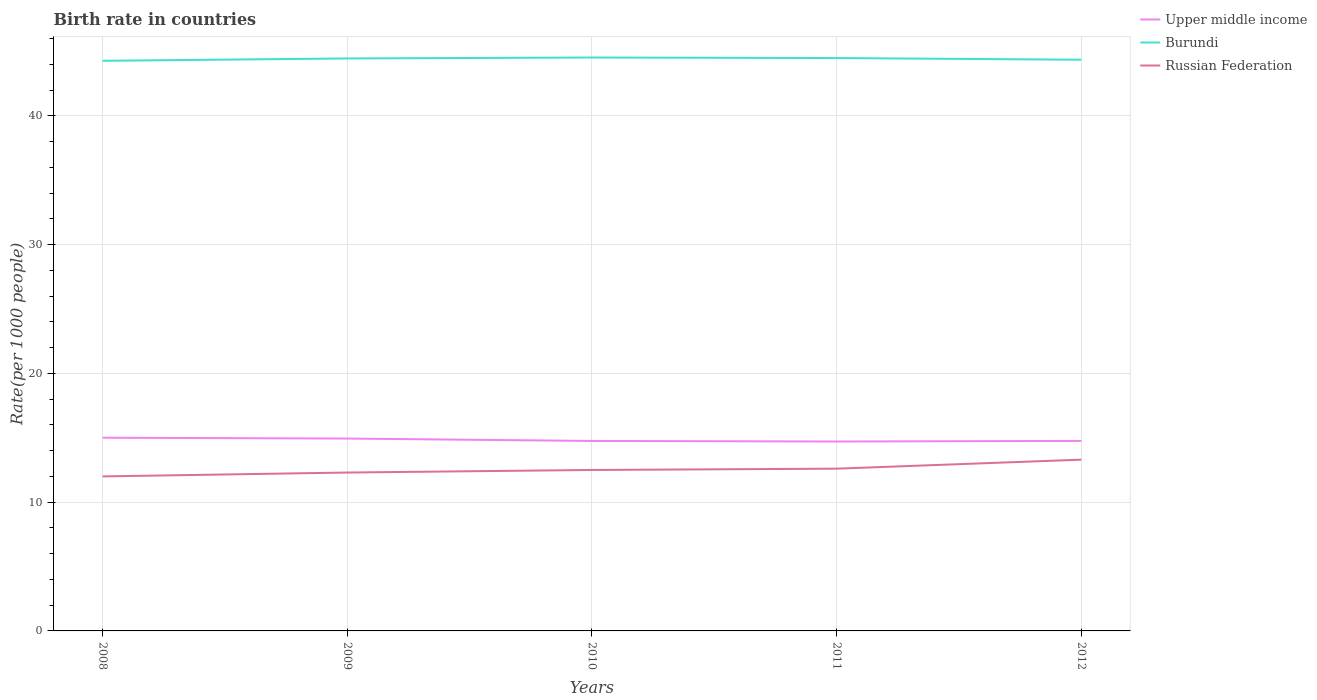Across all years, what is the maximum birth rate in Russian Federation?
Make the answer very short. 12. What is the total birth rate in Russian Federation in the graph?
Make the answer very short. -0.6. What is the difference between the highest and the second highest birth rate in Upper middle income?
Keep it short and to the point. 0.29. How many years are there in the graph?
Ensure brevity in your answer.  5. What is the title of the graph?
Give a very brief answer. Birth rate in countries. Does "Burundi" appear as one of the legend labels in the graph?
Give a very brief answer. Yes. What is the label or title of the X-axis?
Your answer should be very brief. Years. What is the label or title of the Y-axis?
Make the answer very short. Rate(per 1000 people). What is the Rate(per 1000 people) of Upper middle income in 2008?
Offer a terse response. 15.01. What is the Rate(per 1000 people) of Burundi in 2008?
Provide a short and direct response. 44.28. What is the Rate(per 1000 people) of Upper middle income in 2009?
Your answer should be compact. 14.94. What is the Rate(per 1000 people) in Burundi in 2009?
Provide a succinct answer. 44.46. What is the Rate(per 1000 people) of Upper middle income in 2010?
Give a very brief answer. 14.75. What is the Rate(per 1000 people) of Burundi in 2010?
Offer a very short reply. 44.53. What is the Rate(per 1000 people) of Upper middle income in 2011?
Ensure brevity in your answer.  14.71. What is the Rate(per 1000 people) of Burundi in 2011?
Provide a succinct answer. 44.49. What is the Rate(per 1000 people) of Russian Federation in 2011?
Offer a terse response. 12.6. What is the Rate(per 1000 people) in Upper middle income in 2012?
Your answer should be compact. 14.76. What is the Rate(per 1000 people) of Burundi in 2012?
Ensure brevity in your answer.  44.36. What is the Rate(per 1000 people) of Russian Federation in 2012?
Offer a very short reply. 13.3. Across all years, what is the maximum Rate(per 1000 people) of Upper middle income?
Provide a short and direct response. 15.01. Across all years, what is the maximum Rate(per 1000 people) of Burundi?
Make the answer very short. 44.53. Across all years, what is the maximum Rate(per 1000 people) of Russian Federation?
Provide a short and direct response. 13.3. Across all years, what is the minimum Rate(per 1000 people) in Upper middle income?
Your response must be concise. 14.71. Across all years, what is the minimum Rate(per 1000 people) in Burundi?
Make the answer very short. 44.28. What is the total Rate(per 1000 people) in Upper middle income in the graph?
Your answer should be very brief. 74.16. What is the total Rate(per 1000 people) in Burundi in the graph?
Offer a very short reply. 222.11. What is the total Rate(per 1000 people) in Russian Federation in the graph?
Provide a succinct answer. 62.7. What is the difference between the Rate(per 1000 people) in Upper middle income in 2008 and that in 2009?
Your answer should be compact. 0.07. What is the difference between the Rate(per 1000 people) in Burundi in 2008 and that in 2009?
Your answer should be very brief. -0.18. What is the difference between the Rate(per 1000 people) in Upper middle income in 2008 and that in 2010?
Provide a short and direct response. 0.25. What is the difference between the Rate(per 1000 people) in Burundi in 2008 and that in 2010?
Your answer should be compact. -0.25. What is the difference between the Rate(per 1000 people) in Russian Federation in 2008 and that in 2010?
Keep it short and to the point. -0.5. What is the difference between the Rate(per 1000 people) of Upper middle income in 2008 and that in 2011?
Make the answer very short. 0.29. What is the difference between the Rate(per 1000 people) in Burundi in 2008 and that in 2011?
Make the answer very short. -0.21. What is the difference between the Rate(per 1000 people) in Russian Federation in 2008 and that in 2011?
Your response must be concise. -0.6. What is the difference between the Rate(per 1000 people) in Upper middle income in 2008 and that in 2012?
Give a very brief answer. 0.25. What is the difference between the Rate(per 1000 people) in Burundi in 2008 and that in 2012?
Offer a terse response. -0.08. What is the difference between the Rate(per 1000 people) in Russian Federation in 2008 and that in 2012?
Ensure brevity in your answer.  -1.3. What is the difference between the Rate(per 1000 people) in Upper middle income in 2009 and that in 2010?
Make the answer very short. 0.18. What is the difference between the Rate(per 1000 people) in Burundi in 2009 and that in 2010?
Provide a short and direct response. -0.07. What is the difference between the Rate(per 1000 people) in Russian Federation in 2009 and that in 2010?
Keep it short and to the point. -0.2. What is the difference between the Rate(per 1000 people) of Upper middle income in 2009 and that in 2011?
Your response must be concise. 0.23. What is the difference between the Rate(per 1000 people) in Burundi in 2009 and that in 2011?
Give a very brief answer. -0.03. What is the difference between the Rate(per 1000 people) in Russian Federation in 2009 and that in 2011?
Ensure brevity in your answer.  -0.3. What is the difference between the Rate(per 1000 people) of Upper middle income in 2009 and that in 2012?
Ensure brevity in your answer.  0.18. What is the difference between the Rate(per 1000 people) in Burundi in 2009 and that in 2012?
Keep it short and to the point. 0.1. What is the difference between the Rate(per 1000 people) in Russian Federation in 2009 and that in 2012?
Your response must be concise. -1. What is the difference between the Rate(per 1000 people) of Upper middle income in 2010 and that in 2011?
Offer a terse response. 0.04. What is the difference between the Rate(per 1000 people) in Burundi in 2010 and that in 2011?
Your answer should be very brief. 0.04. What is the difference between the Rate(per 1000 people) in Russian Federation in 2010 and that in 2011?
Provide a succinct answer. -0.1. What is the difference between the Rate(per 1000 people) of Upper middle income in 2010 and that in 2012?
Your response must be concise. -0. What is the difference between the Rate(per 1000 people) of Burundi in 2010 and that in 2012?
Your answer should be compact. 0.17. What is the difference between the Rate(per 1000 people) in Russian Federation in 2010 and that in 2012?
Your answer should be compact. -0.8. What is the difference between the Rate(per 1000 people) in Upper middle income in 2011 and that in 2012?
Your answer should be very brief. -0.04. What is the difference between the Rate(per 1000 people) in Burundi in 2011 and that in 2012?
Provide a short and direct response. 0.13. What is the difference between the Rate(per 1000 people) in Russian Federation in 2011 and that in 2012?
Your answer should be compact. -0.7. What is the difference between the Rate(per 1000 people) of Upper middle income in 2008 and the Rate(per 1000 people) of Burundi in 2009?
Your answer should be very brief. -29.45. What is the difference between the Rate(per 1000 people) in Upper middle income in 2008 and the Rate(per 1000 people) in Russian Federation in 2009?
Provide a short and direct response. 2.71. What is the difference between the Rate(per 1000 people) of Burundi in 2008 and the Rate(per 1000 people) of Russian Federation in 2009?
Your response must be concise. 31.98. What is the difference between the Rate(per 1000 people) of Upper middle income in 2008 and the Rate(per 1000 people) of Burundi in 2010?
Keep it short and to the point. -29.52. What is the difference between the Rate(per 1000 people) in Upper middle income in 2008 and the Rate(per 1000 people) in Russian Federation in 2010?
Give a very brief answer. 2.51. What is the difference between the Rate(per 1000 people) in Burundi in 2008 and the Rate(per 1000 people) in Russian Federation in 2010?
Offer a very short reply. 31.78. What is the difference between the Rate(per 1000 people) of Upper middle income in 2008 and the Rate(per 1000 people) of Burundi in 2011?
Ensure brevity in your answer.  -29.48. What is the difference between the Rate(per 1000 people) of Upper middle income in 2008 and the Rate(per 1000 people) of Russian Federation in 2011?
Your response must be concise. 2.41. What is the difference between the Rate(per 1000 people) in Burundi in 2008 and the Rate(per 1000 people) in Russian Federation in 2011?
Make the answer very short. 31.68. What is the difference between the Rate(per 1000 people) of Upper middle income in 2008 and the Rate(per 1000 people) of Burundi in 2012?
Make the answer very short. -29.35. What is the difference between the Rate(per 1000 people) in Upper middle income in 2008 and the Rate(per 1000 people) in Russian Federation in 2012?
Offer a terse response. 1.71. What is the difference between the Rate(per 1000 people) in Burundi in 2008 and the Rate(per 1000 people) in Russian Federation in 2012?
Your answer should be very brief. 30.98. What is the difference between the Rate(per 1000 people) in Upper middle income in 2009 and the Rate(per 1000 people) in Burundi in 2010?
Offer a terse response. -29.59. What is the difference between the Rate(per 1000 people) in Upper middle income in 2009 and the Rate(per 1000 people) in Russian Federation in 2010?
Provide a succinct answer. 2.44. What is the difference between the Rate(per 1000 people) of Burundi in 2009 and the Rate(per 1000 people) of Russian Federation in 2010?
Give a very brief answer. 31.96. What is the difference between the Rate(per 1000 people) in Upper middle income in 2009 and the Rate(per 1000 people) in Burundi in 2011?
Make the answer very short. -29.55. What is the difference between the Rate(per 1000 people) in Upper middle income in 2009 and the Rate(per 1000 people) in Russian Federation in 2011?
Provide a succinct answer. 2.34. What is the difference between the Rate(per 1000 people) in Burundi in 2009 and the Rate(per 1000 people) in Russian Federation in 2011?
Provide a short and direct response. 31.86. What is the difference between the Rate(per 1000 people) in Upper middle income in 2009 and the Rate(per 1000 people) in Burundi in 2012?
Give a very brief answer. -29.42. What is the difference between the Rate(per 1000 people) in Upper middle income in 2009 and the Rate(per 1000 people) in Russian Federation in 2012?
Offer a very short reply. 1.64. What is the difference between the Rate(per 1000 people) of Burundi in 2009 and the Rate(per 1000 people) of Russian Federation in 2012?
Provide a short and direct response. 31.16. What is the difference between the Rate(per 1000 people) of Upper middle income in 2010 and the Rate(per 1000 people) of Burundi in 2011?
Ensure brevity in your answer.  -29.74. What is the difference between the Rate(per 1000 people) of Upper middle income in 2010 and the Rate(per 1000 people) of Russian Federation in 2011?
Ensure brevity in your answer.  2.15. What is the difference between the Rate(per 1000 people) of Burundi in 2010 and the Rate(per 1000 people) of Russian Federation in 2011?
Provide a succinct answer. 31.93. What is the difference between the Rate(per 1000 people) in Upper middle income in 2010 and the Rate(per 1000 people) in Burundi in 2012?
Your response must be concise. -29.6. What is the difference between the Rate(per 1000 people) of Upper middle income in 2010 and the Rate(per 1000 people) of Russian Federation in 2012?
Offer a terse response. 1.45. What is the difference between the Rate(per 1000 people) of Burundi in 2010 and the Rate(per 1000 people) of Russian Federation in 2012?
Your answer should be very brief. 31.23. What is the difference between the Rate(per 1000 people) of Upper middle income in 2011 and the Rate(per 1000 people) of Burundi in 2012?
Give a very brief answer. -29.65. What is the difference between the Rate(per 1000 people) of Upper middle income in 2011 and the Rate(per 1000 people) of Russian Federation in 2012?
Make the answer very short. 1.41. What is the difference between the Rate(per 1000 people) of Burundi in 2011 and the Rate(per 1000 people) of Russian Federation in 2012?
Provide a succinct answer. 31.19. What is the average Rate(per 1000 people) in Upper middle income per year?
Provide a succinct answer. 14.83. What is the average Rate(per 1000 people) of Burundi per year?
Provide a succinct answer. 44.42. What is the average Rate(per 1000 people) of Russian Federation per year?
Make the answer very short. 12.54. In the year 2008, what is the difference between the Rate(per 1000 people) in Upper middle income and Rate(per 1000 people) in Burundi?
Make the answer very short. -29.27. In the year 2008, what is the difference between the Rate(per 1000 people) of Upper middle income and Rate(per 1000 people) of Russian Federation?
Make the answer very short. 3.01. In the year 2008, what is the difference between the Rate(per 1000 people) in Burundi and Rate(per 1000 people) in Russian Federation?
Your response must be concise. 32.28. In the year 2009, what is the difference between the Rate(per 1000 people) of Upper middle income and Rate(per 1000 people) of Burundi?
Your answer should be very brief. -29.52. In the year 2009, what is the difference between the Rate(per 1000 people) in Upper middle income and Rate(per 1000 people) in Russian Federation?
Your response must be concise. 2.64. In the year 2009, what is the difference between the Rate(per 1000 people) in Burundi and Rate(per 1000 people) in Russian Federation?
Provide a short and direct response. 32.16. In the year 2010, what is the difference between the Rate(per 1000 people) of Upper middle income and Rate(per 1000 people) of Burundi?
Your answer should be compact. -29.78. In the year 2010, what is the difference between the Rate(per 1000 people) of Upper middle income and Rate(per 1000 people) of Russian Federation?
Offer a terse response. 2.25. In the year 2010, what is the difference between the Rate(per 1000 people) of Burundi and Rate(per 1000 people) of Russian Federation?
Your answer should be very brief. 32.03. In the year 2011, what is the difference between the Rate(per 1000 people) of Upper middle income and Rate(per 1000 people) of Burundi?
Your answer should be very brief. -29.78. In the year 2011, what is the difference between the Rate(per 1000 people) of Upper middle income and Rate(per 1000 people) of Russian Federation?
Your response must be concise. 2.11. In the year 2011, what is the difference between the Rate(per 1000 people) of Burundi and Rate(per 1000 people) of Russian Federation?
Provide a short and direct response. 31.89. In the year 2012, what is the difference between the Rate(per 1000 people) of Upper middle income and Rate(per 1000 people) of Burundi?
Your response must be concise. -29.6. In the year 2012, what is the difference between the Rate(per 1000 people) of Upper middle income and Rate(per 1000 people) of Russian Federation?
Keep it short and to the point. 1.46. In the year 2012, what is the difference between the Rate(per 1000 people) in Burundi and Rate(per 1000 people) in Russian Federation?
Your answer should be very brief. 31.06. What is the ratio of the Rate(per 1000 people) in Burundi in 2008 to that in 2009?
Offer a terse response. 1. What is the ratio of the Rate(per 1000 people) in Russian Federation in 2008 to that in 2009?
Offer a terse response. 0.98. What is the ratio of the Rate(per 1000 people) of Upper middle income in 2008 to that in 2010?
Your answer should be very brief. 1.02. What is the ratio of the Rate(per 1000 people) of Russian Federation in 2008 to that in 2010?
Offer a terse response. 0.96. What is the ratio of the Rate(per 1000 people) in Upper middle income in 2008 to that in 2011?
Provide a succinct answer. 1.02. What is the ratio of the Rate(per 1000 people) in Burundi in 2008 to that in 2011?
Offer a very short reply. 1. What is the ratio of the Rate(per 1000 people) of Russian Federation in 2008 to that in 2011?
Ensure brevity in your answer.  0.95. What is the ratio of the Rate(per 1000 people) of Upper middle income in 2008 to that in 2012?
Offer a very short reply. 1.02. What is the ratio of the Rate(per 1000 people) of Russian Federation in 2008 to that in 2012?
Give a very brief answer. 0.9. What is the ratio of the Rate(per 1000 people) in Upper middle income in 2009 to that in 2010?
Ensure brevity in your answer.  1.01. What is the ratio of the Rate(per 1000 people) of Russian Federation in 2009 to that in 2010?
Offer a very short reply. 0.98. What is the ratio of the Rate(per 1000 people) of Upper middle income in 2009 to that in 2011?
Make the answer very short. 1.02. What is the ratio of the Rate(per 1000 people) in Russian Federation in 2009 to that in 2011?
Make the answer very short. 0.98. What is the ratio of the Rate(per 1000 people) of Upper middle income in 2009 to that in 2012?
Offer a terse response. 1.01. What is the ratio of the Rate(per 1000 people) of Russian Federation in 2009 to that in 2012?
Give a very brief answer. 0.92. What is the ratio of the Rate(per 1000 people) of Upper middle income in 2010 to that in 2011?
Ensure brevity in your answer.  1. What is the ratio of the Rate(per 1000 people) in Burundi in 2010 to that in 2012?
Provide a short and direct response. 1. What is the ratio of the Rate(per 1000 people) of Russian Federation in 2010 to that in 2012?
Offer a very short reply. 0.94. What is the ratio of the Rate(per 1000 people) in Burundi in 2011 to that in 2012?
Ensure brevity in your answer.  1. What is the ratio of the Rate(per 1000 people) of Russian Federation in 2011 to that in 2012?
Your response must be concise. 0.95. What is the difference between the highest and the second highest Rate(per 1000 people) of Upper middle income?
Your response must be concise. 0.07. What is the difference between the highest and the second highest Rate(per 1000 people) of Burundi?
Offer a terse response. 0.04. What is the difference between the highest and the second highest Rate(per 1000 people) of Russian Federation?
Make the answer very short. 0.7. What is the difference between the highest and the lowest Rate(per 1000 people) of Upper middle income?
Give a very brief answer. 0.29. What is the difference between the highest and the lowest Rate(per 1000 people) in Burundi?
Your answer should be compact. 0.25. 